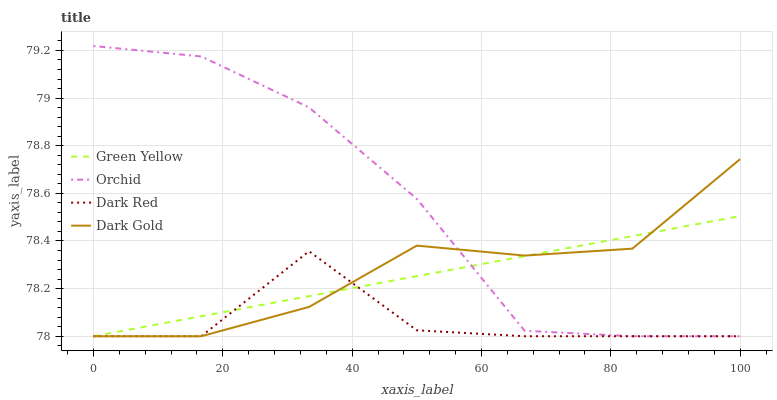Does Green Yellow have the minimum area under the curve?
Answer yes or no. No. Does Green Yellow have the maximum area under the curve?
Answer yes or no. No. Is Dark Gold the smoothest?
Answer yes or no. No. Is Dark Gold the roughest?
Answer yes or no. No. Does Green Yellow have the highest value?
Answer yes or no. No. 